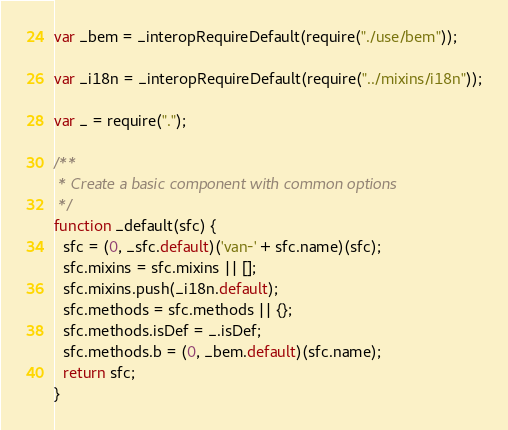<code> <loc_0><loc_0><loc_500><loc_500><_JavaScript_>var _bem = _interopRequireDefault(require("./use/bem"));

var _i18n = _interopRequireDefault(require("../mixins/i18n"));

var _ = require(".");

/**
 * Create a basic component with common options
 */
function _default(sfc) {
  sfc = (0, _sfc.default)('van-' + sfc.name)(sfc);
  sfc.mixins = sfc.mixins || [];
  sfc.mixins.push(_i18n.default);
  sfc.methods = sfc.methods || {};
  sfc.methods.isDef = _.isDef;
  sfc.methods.b = (0, _bem.default)(sfc.name);
  return sfc;
}</code> 